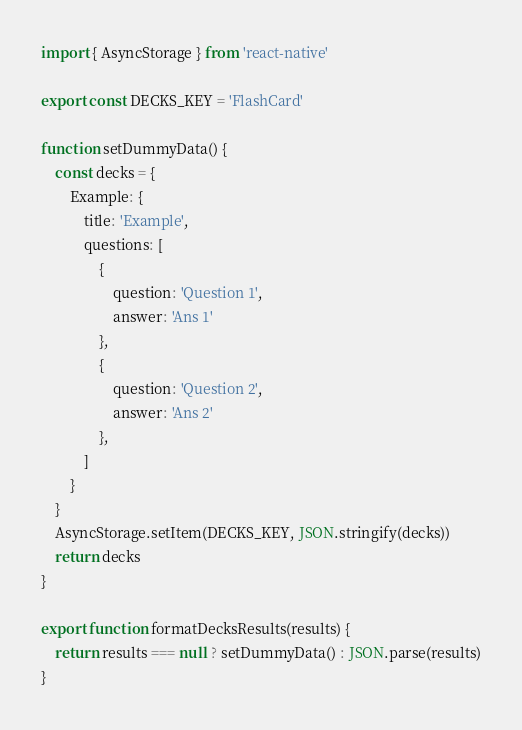<code> <loc_0><loc_0><loc_500><loc_500><_JavaScript_>import { AsyncStorage } from 'react-native'

export const DECKS_KEY = 'FlashCard'

function setDummyData() {
    const decks = {
        Example: {
            title: 'Example',
            questions: [
                {
                    question: 'Question 1',
                    answer: 'Ans 1'
                },
                {
                    question: 'Question 2',
                    answer: 'Ans 2'
                },
            ]
        }
    }
    AsyncStorage.setItem(DECKS_KEY, JSON.stringify(decks))
    return decks
}

export function formatDecksResults(results) {
    return results === null ? setDummyData() : JSON.parse(results)
}
</code> 